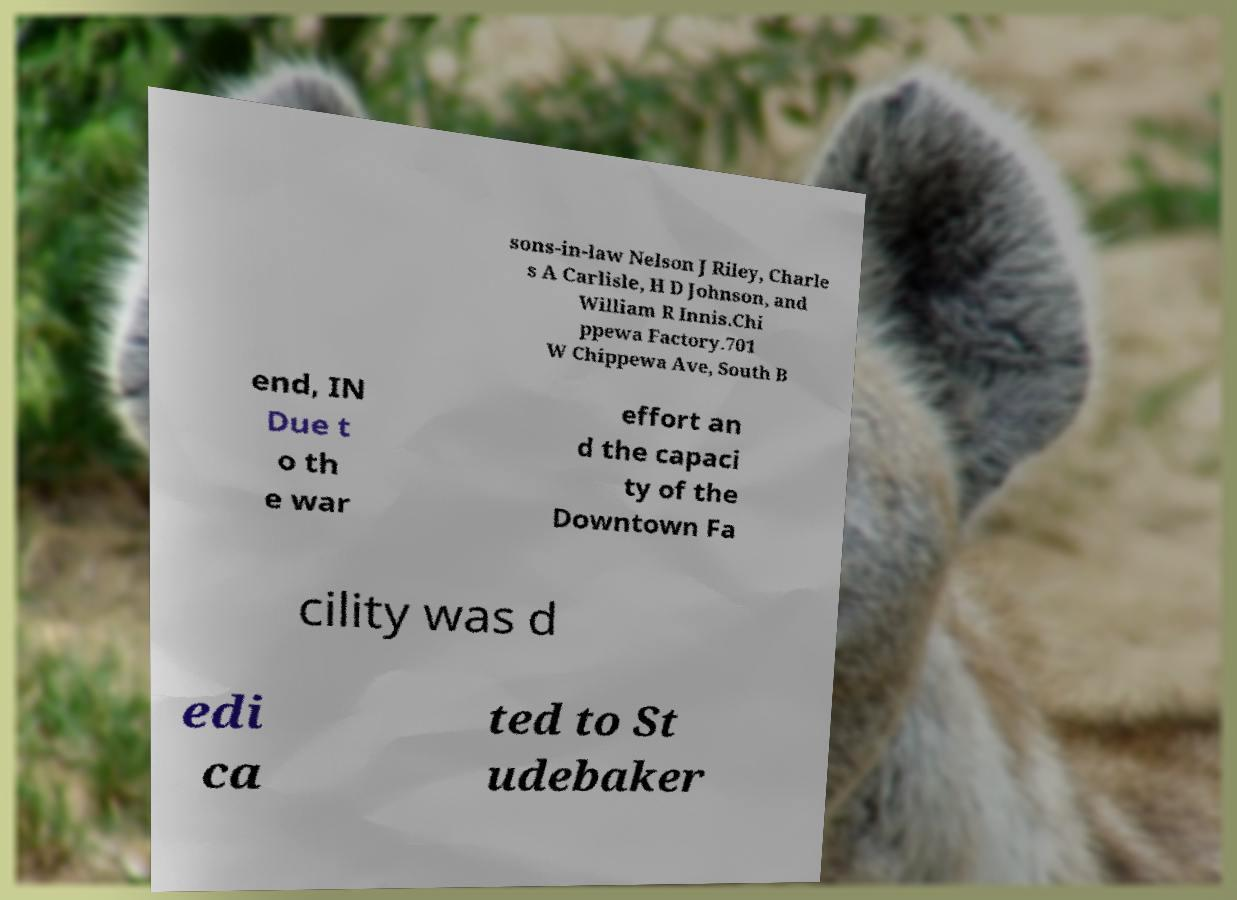Please read and relay the text visible in this image. What does it say? sons-in-law Nelson J Riley, Charle s A Carlisle, H D Johnson, and William R Innis.Chi ppewa Factory.701 W Chippewa Ave, South B end, IN Due t o th e war effort an d the capaci ty of the Downtown Fa cility was d edi ca ted to St udebaker 